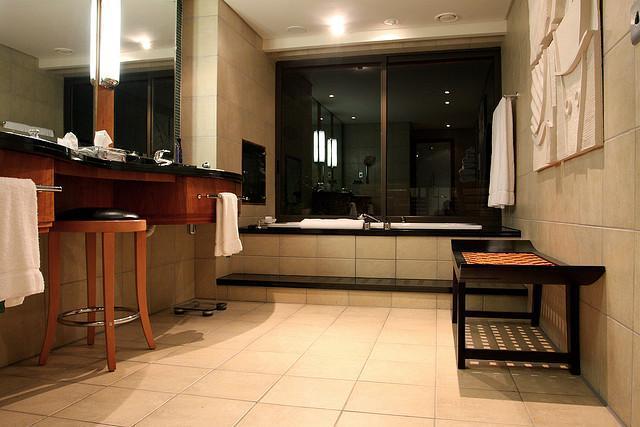How many towels are hanging?
Give a very brief answer. 3. 